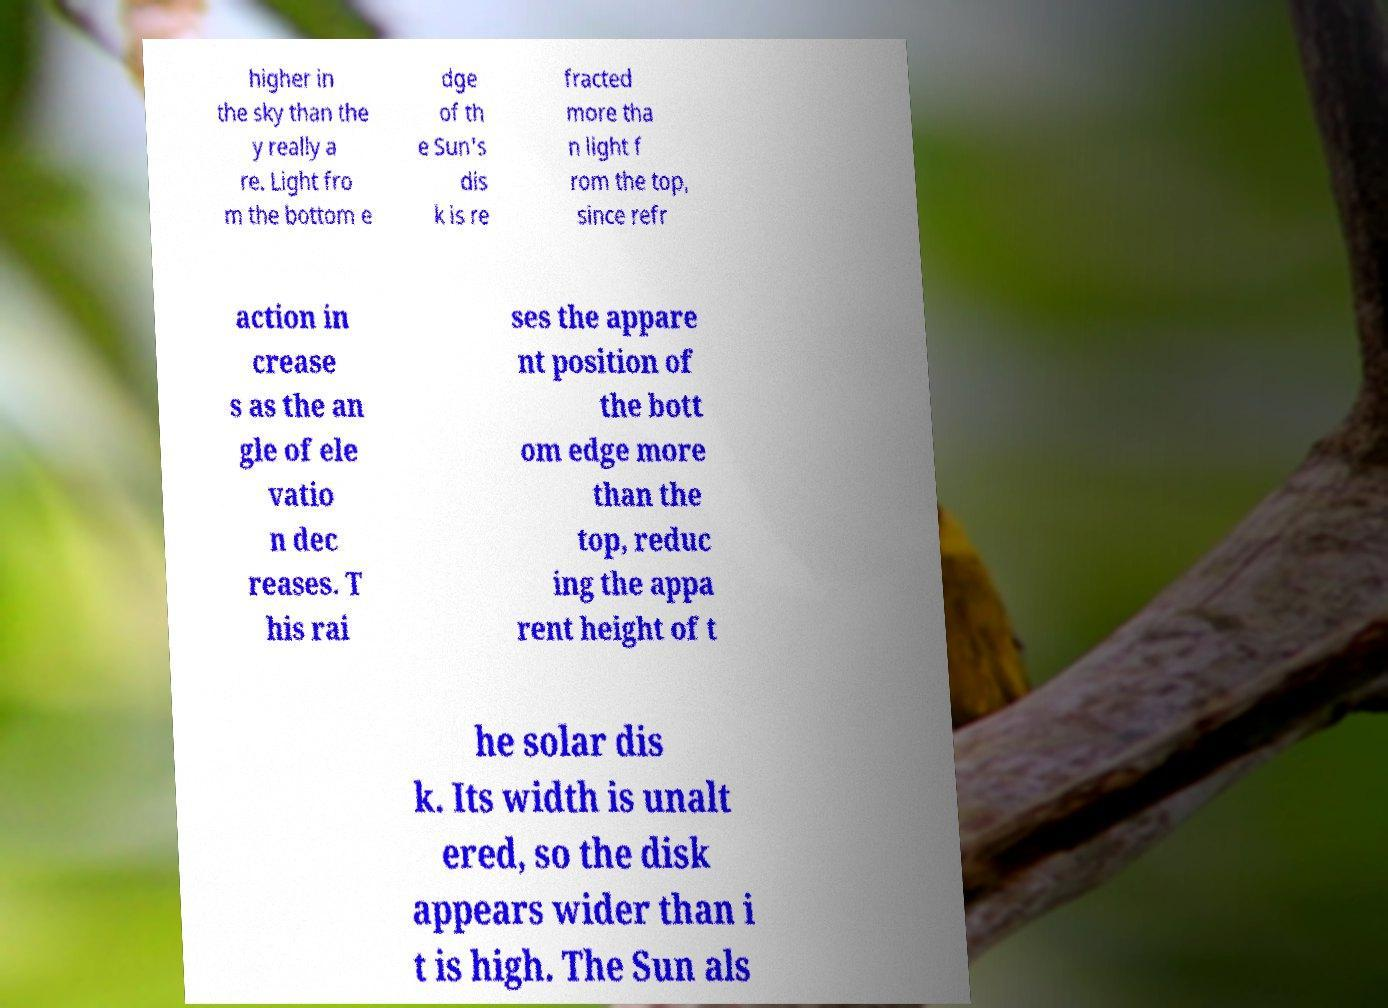What messages or text are displayed in this image? I need them in a readable, typed format. higher in the sky than the y really a re. Light fro m the bottom e dge of th e Sun's dis k is re fracted more tha n light f rom the top, since refr action in crease s as the an gle of ele vatio n dec reases. T his rai ses the appare nt position of the bott om edge more than the top, reduc ing the appa rent height of t he solar dis k. Its width is unalt ered, so the disk appears wider than i t is high. The Sun als 